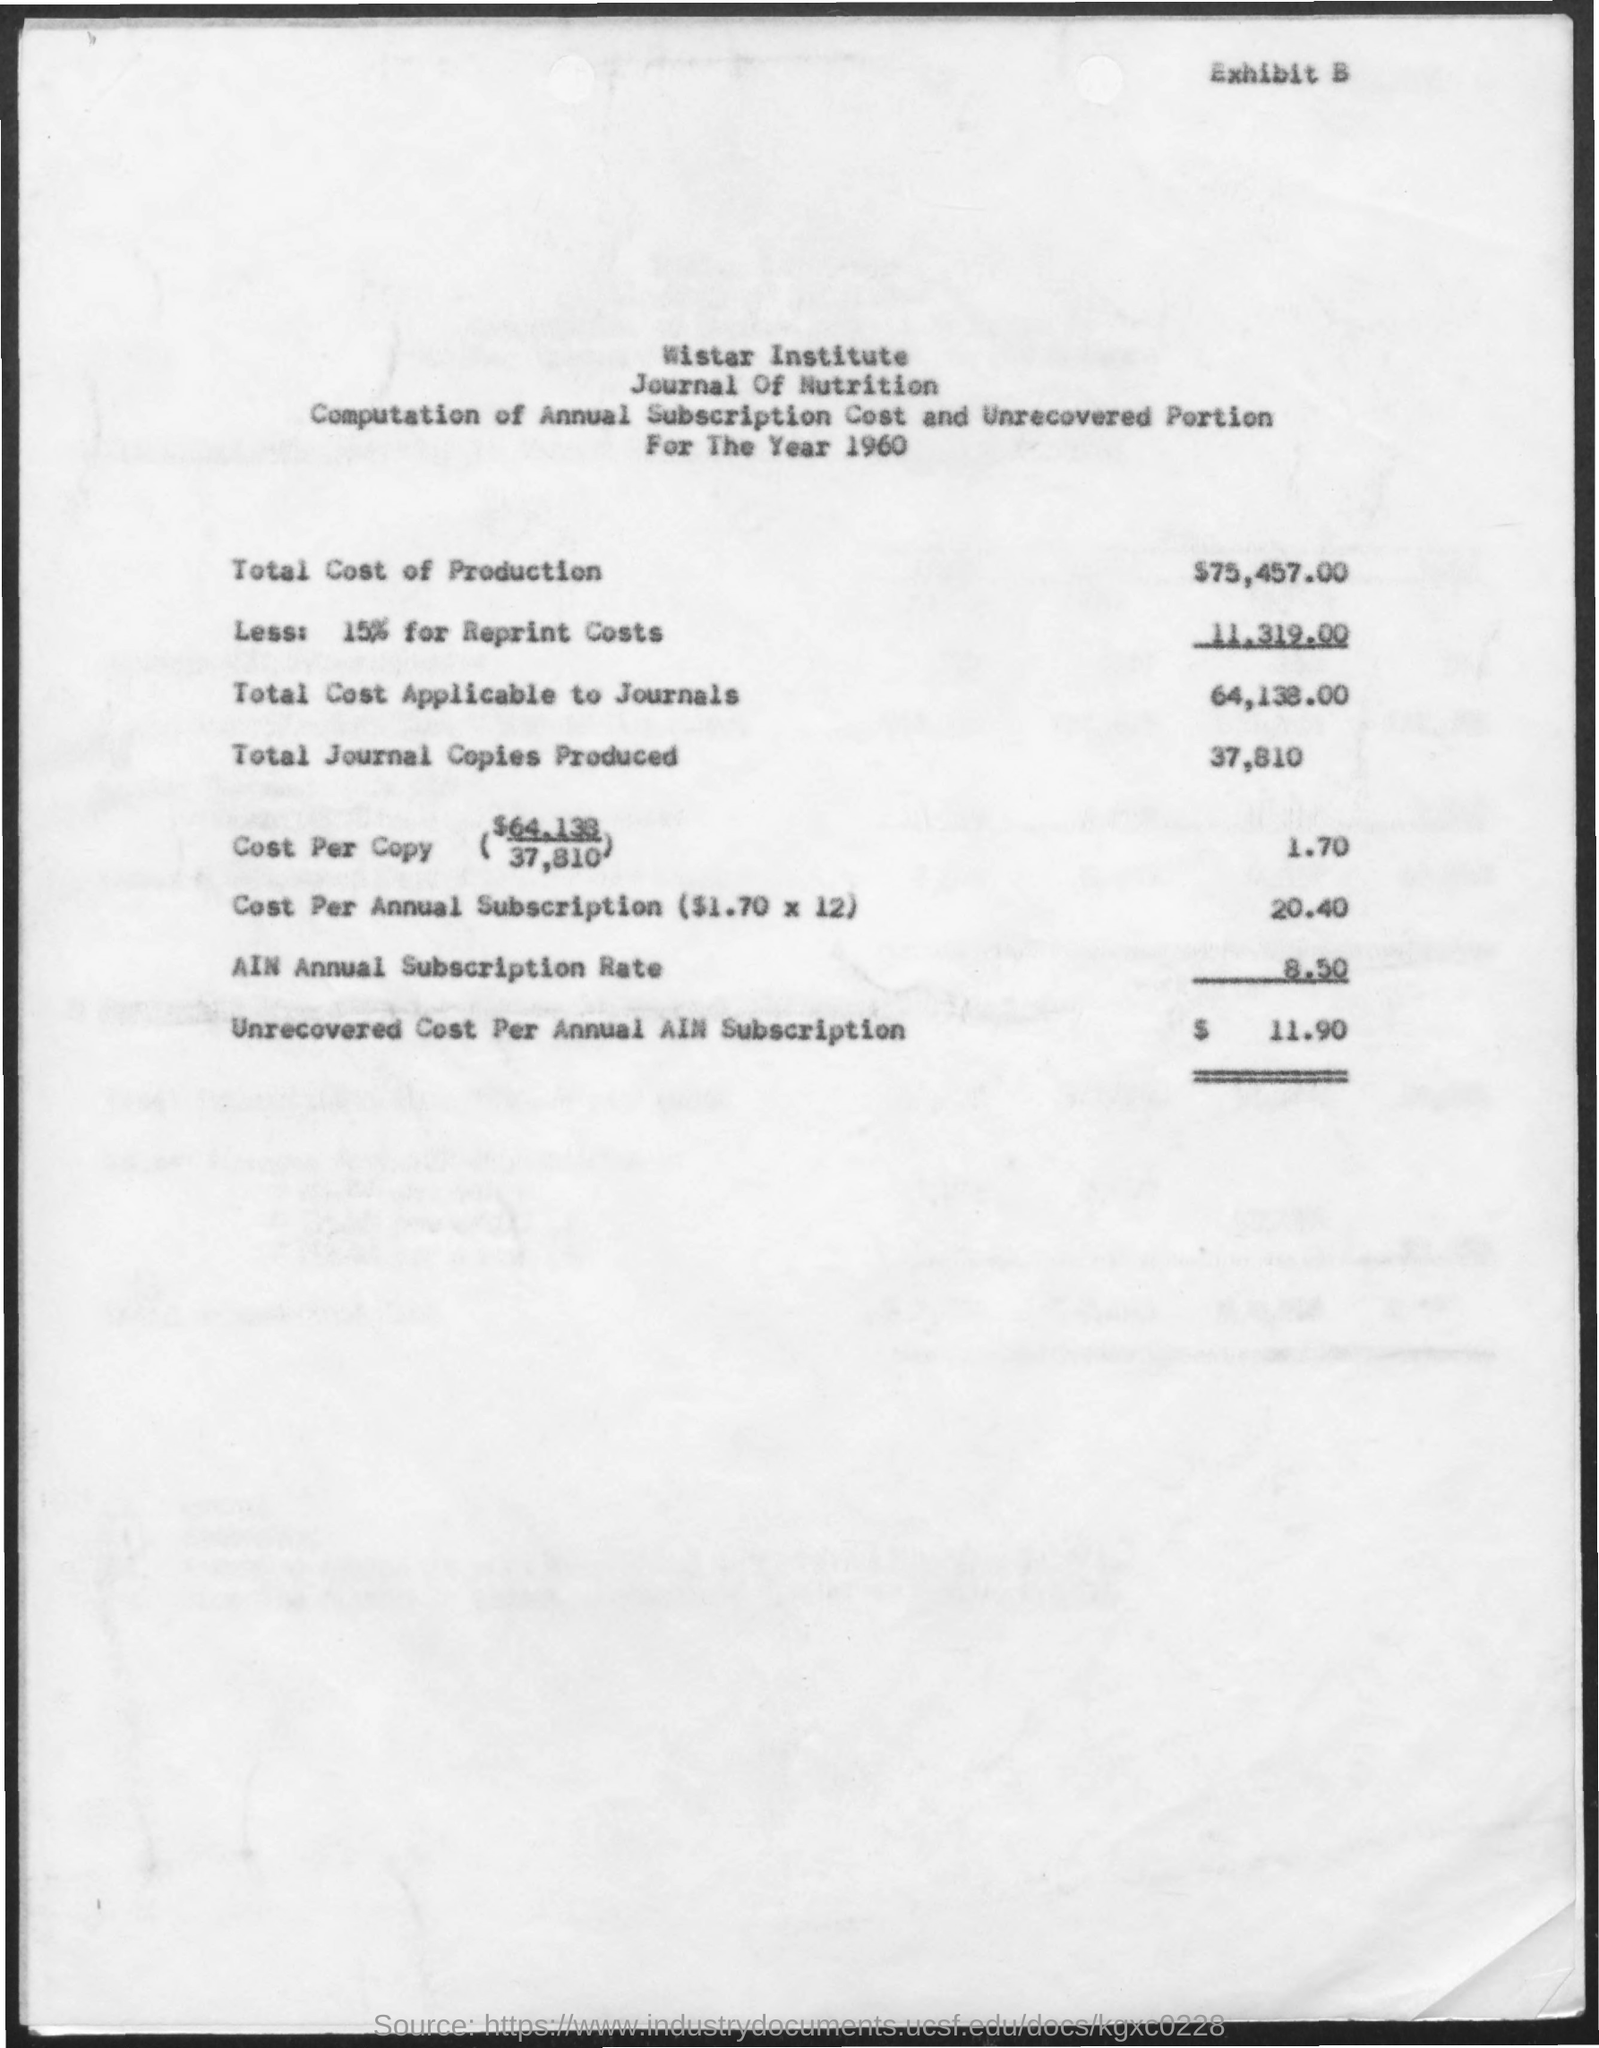Mention a couple of crucial points in this snapshot. The total cost of production is $75,457.00. The Wistar Institute is the name of the institute mentioned. The cost per annual AIN subscription that has not been recovered is $11.90. The year mentioned is 1960. 